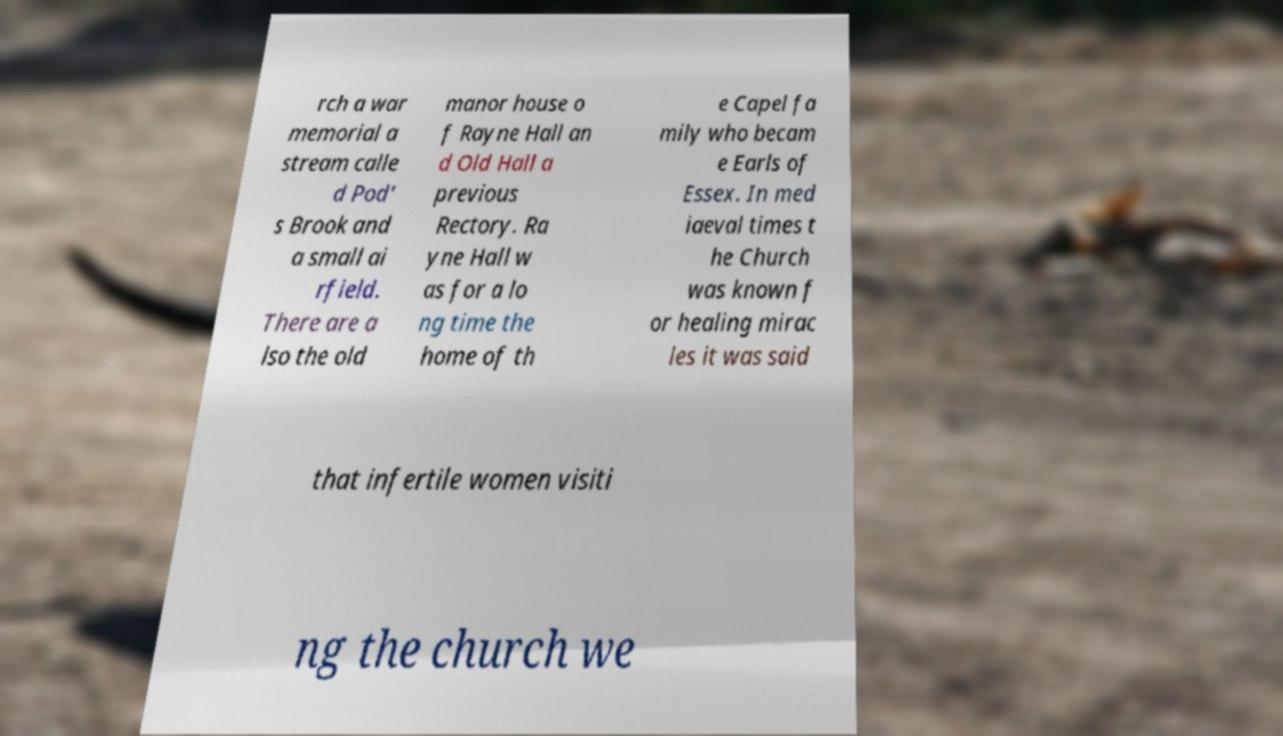Please identify and transcribe the text found in this image. rch a war memorial a stream calle d Pod' s Brook and a small ai rfield. There are a lso the old manor house o f Rayne Hall an d Old Hall a previous Rectory. Ra yne Hall w as for a lo ng time the home of th e Capel fa mily who becam e Earls of Essex. In med iaeval times t he Church was known f or healing mirac les it was said that infertile women visiti ng the church we 